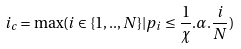<formula> <loc_0><loc_0><loc_500><loc_500>i _ { c } = \max ( i \in \{ 1 , . . , N \} | p _ { i } \leq \frac { 1 } { \chi } . \alpha . \frac { i } { N } )</formula> 